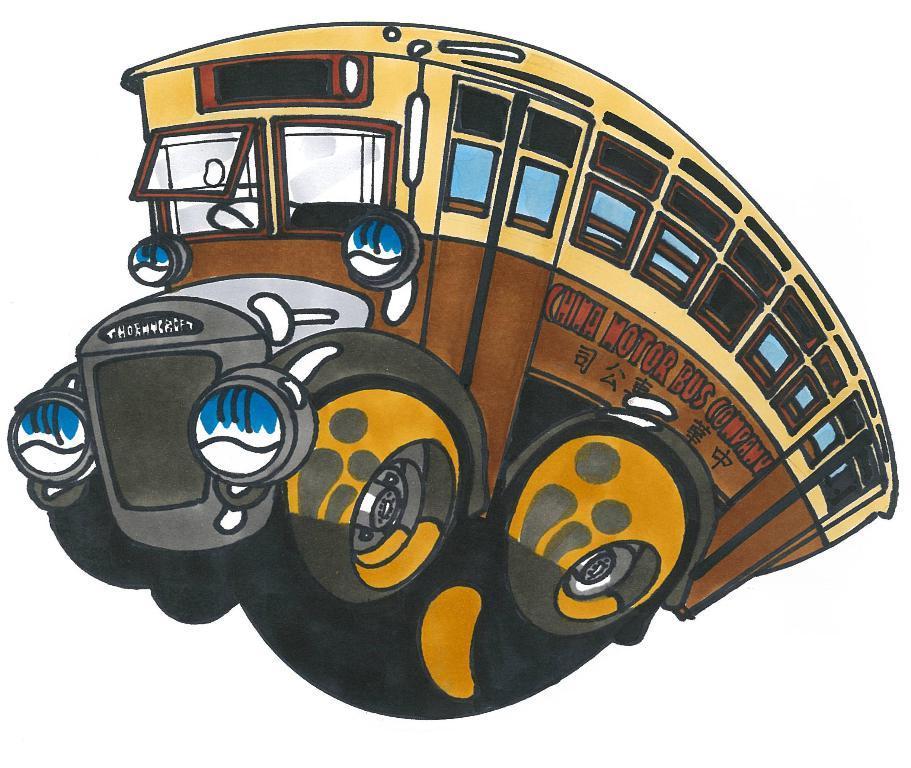Please provide a concise description of this image. In this image, I think this is the drawing of a bus. I can see the doors, windows, steering wheel, headlights and the wheels of a bus. 